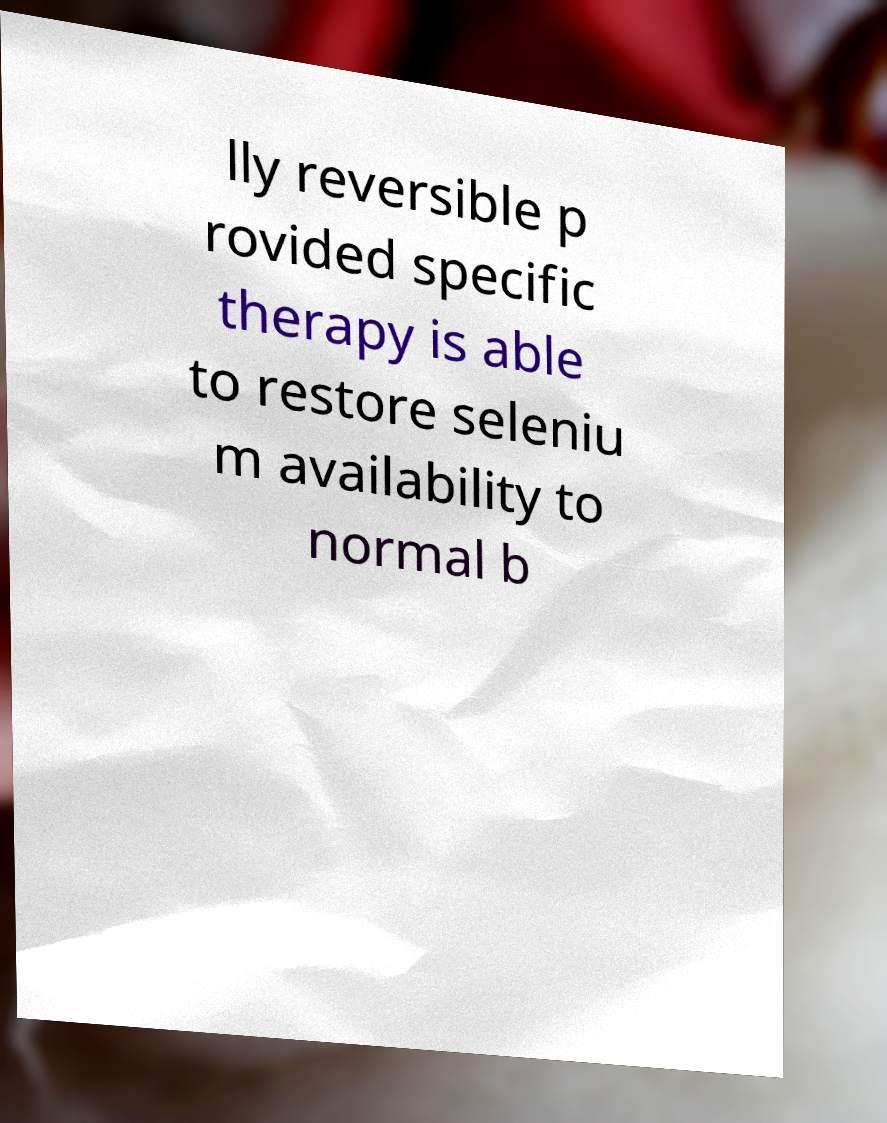There's text embedded in this image that I need extracted. Can you transcribe it verbatim? lly reversible p rovided specific therapy is able to restore seleniu m availability to normal b 